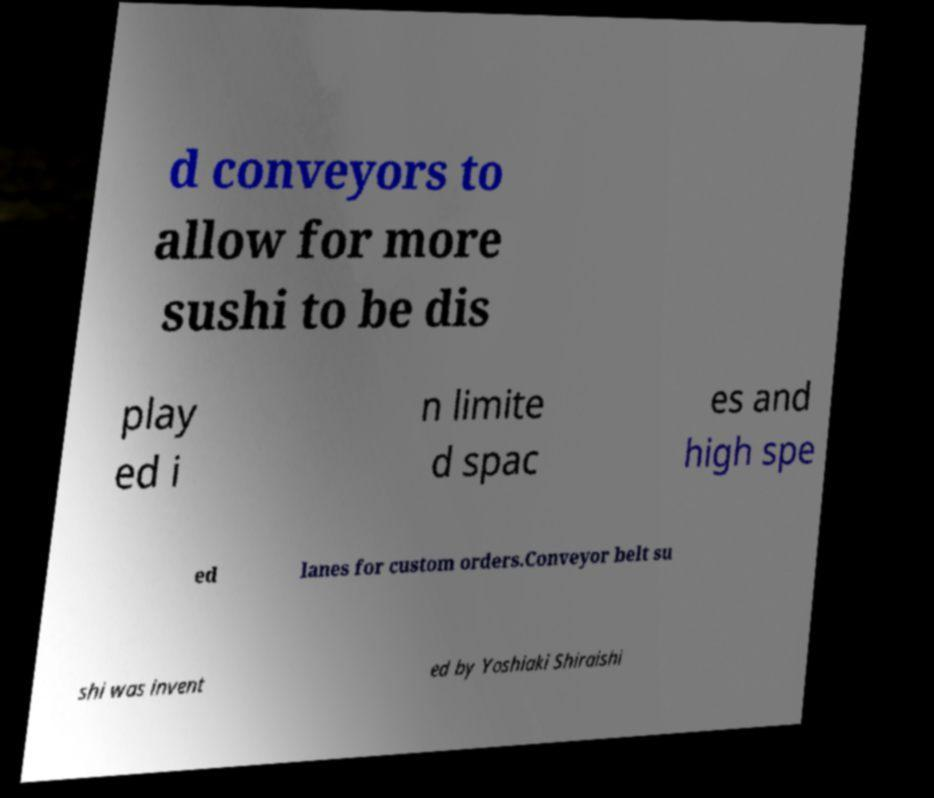Can you accurately transcribe the text from the provided image for me? d conveyors to allow for more sushi to be dis play ed i n limite d spac es and high spe ed lanes for custom orders.Conveyor belt su shi was invent ed by Yoshiaki Shiraishi 